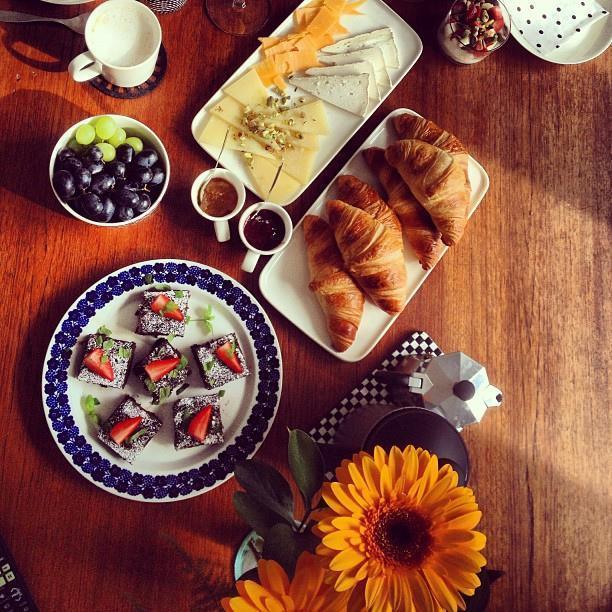How many pastry are on the table?
Give a very brief answer. 6. How many bowls are visible?
Give a very brief answer. 2. How many cups can you see?
Give a very brief answer. 4. 